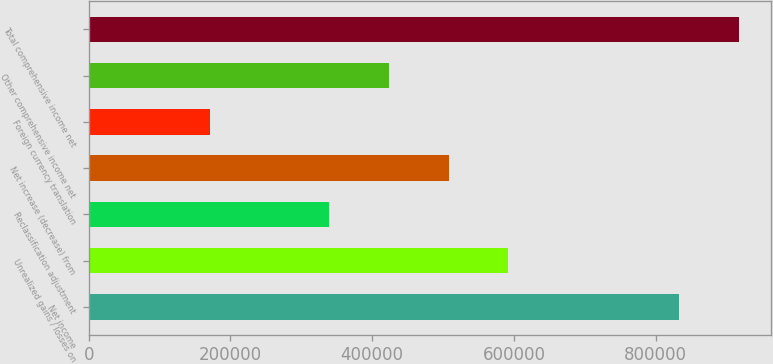<chart> <loc_0><loc_0><loc_500><loc_500><bar_chart><fcel>Net income<fcel>Unrealized gains / losses on<fcel>Reclassification adjustment<fcel>Net increase (decrease) from<fcel>Foreign currency translation<fcel>Other comprehensive income net<fcel>Total comprehensive income net<nl><fcel>832847<fcel>592297<fcel>339225<fcel>507939<fcel>170510<fcel>423582<fcel>917204<nl></chart> 